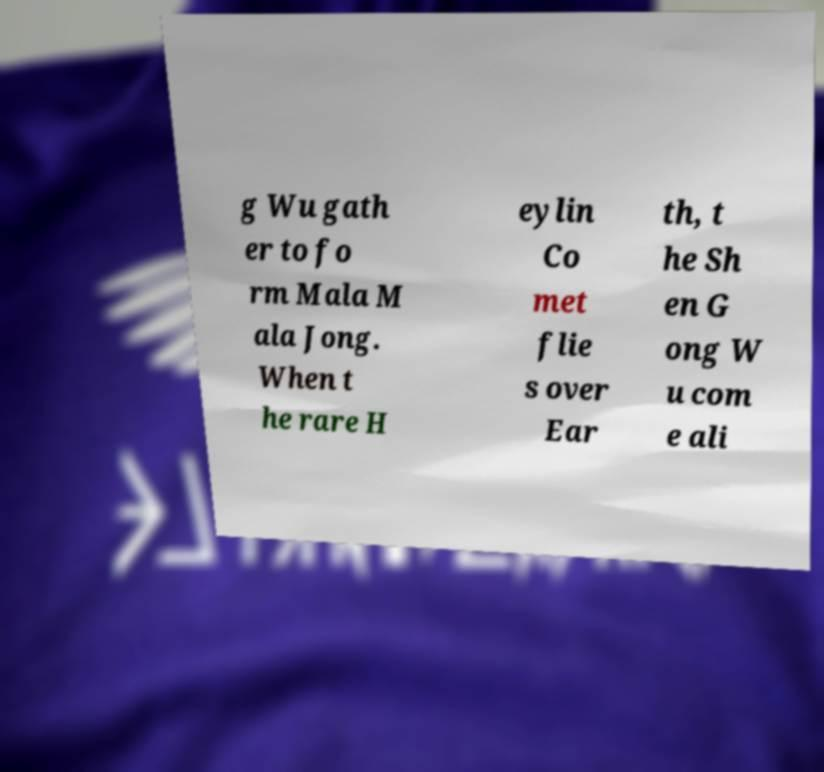There's text embedded in this image that I need extracted. Can you transcribe it verbatim? g Wu gath er to fo rm Mala M ala Jong. When t he rare H eylin Co met flie s over Ear th, t he Sh en G ong W u com e ali 